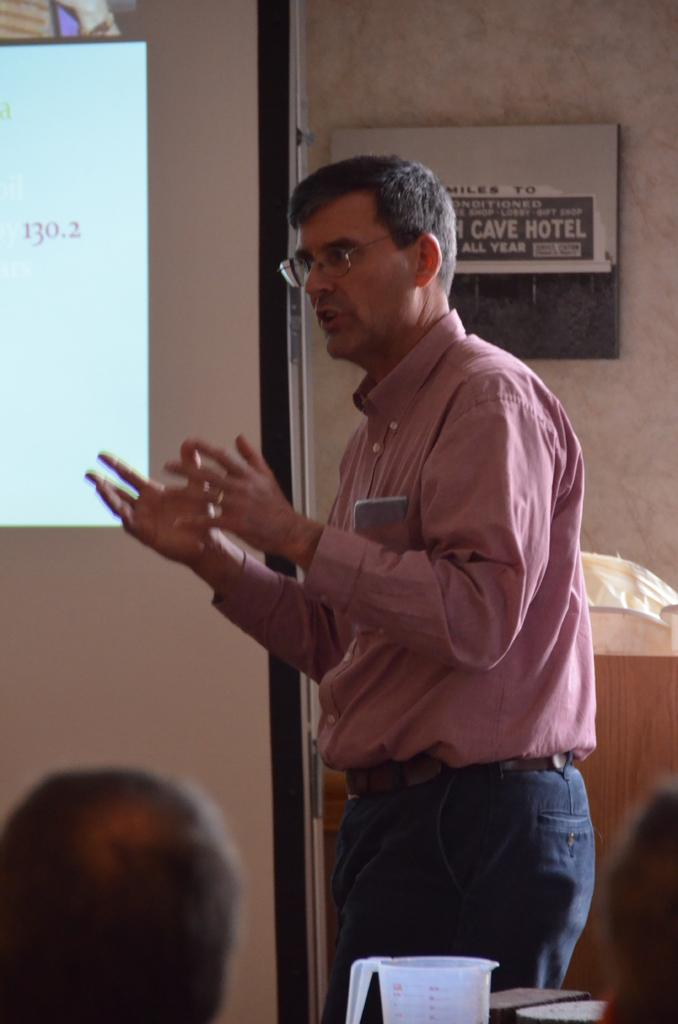What is the person in the image doing? There is a person standing and talking in the image. What part of the person's body is visible in the image? The person's head is visible in the image. What object can be seen near the person? There is a mug in the image. What can be seen on a board in the image? There is a display on a board in the image. Is the person in the image a spy, and what watch are they wearing? There is no indication in the image that the person is a spy, and no watch is visible in the image. What type of cup is being used by the person in the image? There is no cup visible in the image; only a mug is present. 